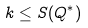Convert formula to latex. <formula><loc_0><loc_0><loc_500><loc_500>k \leq S ( Q ^ { * } )</formula> 